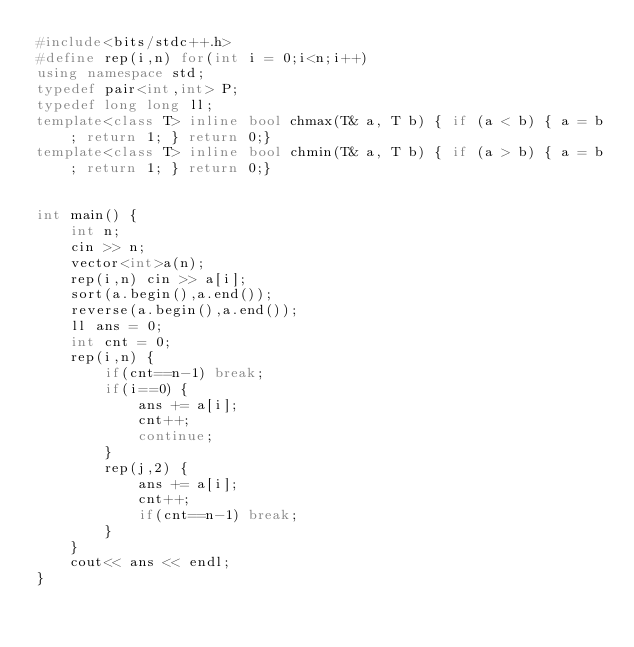<code> <loc_0><loc_0><loc_500><loc_500><_C++_>#include<bits/stdc++.h>
#define rep(i,n) for(int i = 0;i<n;i++)
using namespace std;
typedef pair<int,int> P;
typedef long long ll;
template<class T> inline bool chmax(T& a, T b) { if (a < b) { a = b; return 1; } return 0;}
template<class T> inline bool chmin(T& a, T b) { if (a > b) { a = b; return 1; } return 0;}


int main() {
    int n;
    cin >> n;
    vector<int>a(n);
    rep(i,n) cin >> a[i];
    sort(a.begin(),a.end());
    reverse(a.begin(),a.end());
    ll ans = 0;
    int cnt = 0;
    rep(i,n) {
        if(cnt==n-1) break;
        if(i==0) {
            ans += a[i];
            cnt++;
            continue;
        }
        rep(j,2) {
            ans += a[i];
            cnt++;
            if(cnt==n-1) break;
        }
    }
    cout<< ans << endl;
}
    


</code> 